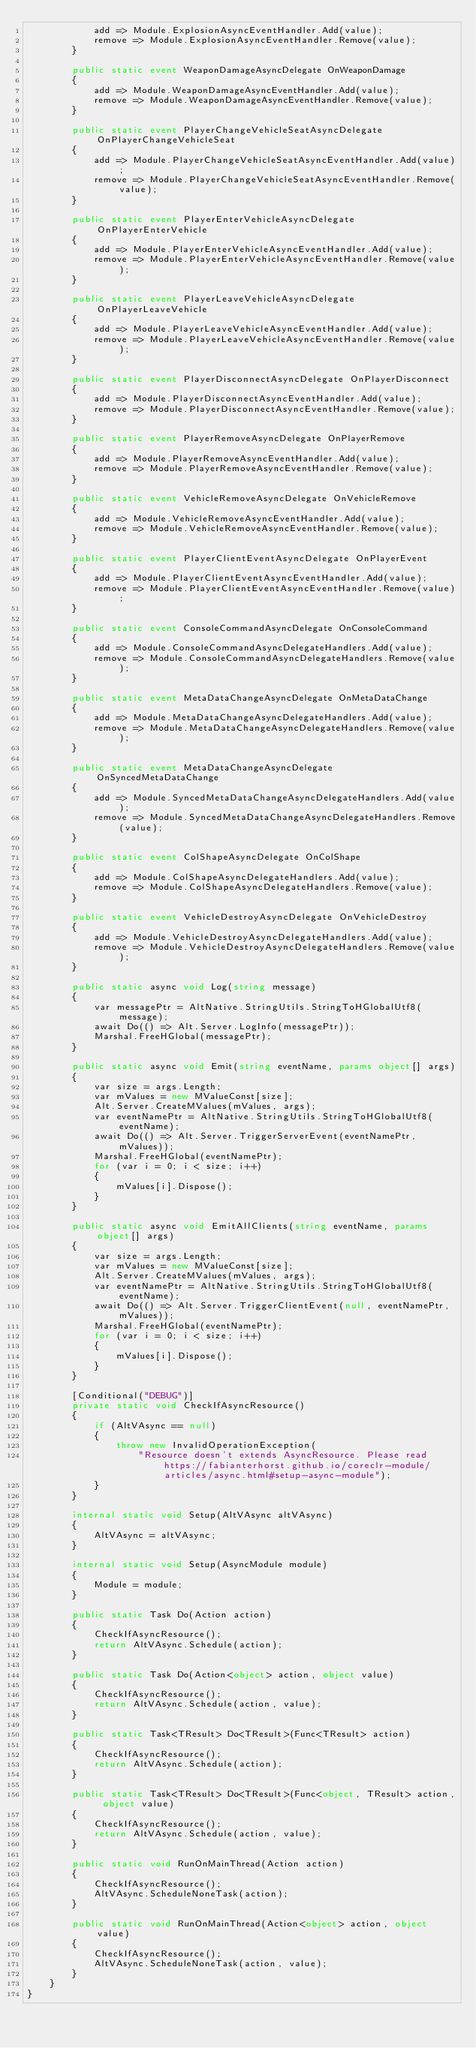<code> <loc_0><loc_0><loc_500><loc_500><_C#_>            add => Module.ExplosionAsyncEventHandler.Add(value);
            remove => Module.ExplosionAsyncEventHandler.Remove(value);
        }

        public static event WeaponDamageAsyncDelegate OnWeaponDamage
        {
            add => Module.WeaponDamageAsyncEventHandler.Add(value);
            remove => Module.WeaponDamageAsyncEventHandler.Remove(value);
        }

        public static event PlayerChangeVehicleSeatAsyncDelegate OnPlayerChangeVehicleSeat
        {
            add => Module.PlayerChangeVehicleSeatAsyncEventHandler.Add(value);
            remove => Module.PlayerChangeVehicleSeatAsyncEventHandler.Remove(value);
        }

        public static event PlayerEnterVehicleAsyncDelegate OnPlayerEnterVehicle
        {
            add => Module.PlayerEnterVehicleAsyncEventHandler.Add(value);
            remove => Module.PlayerEnterVehicleAsyncEventHandler.Remove(value);
        }

        public static event PlayerLeaveVehicleAsyncDelegate OnPlayerLeaveVehicle
        {
            add => Module.PlayerLeaveVehicleAsyncEventHandler.Add(value);
            remove => Module.PlayerLeaveVehicleAsyncEventHandler.Remove(value);
        }

        public static event PlayerDisconnectAsyncDelegate OnPlayerDisconnect
        {
            add => Module.PlayerDisconnectAsyncEventHandler.Add(value);
            remove => Module.PlayerDisconnectAsyncEventHandler.Remove(value);
        }

        public static event PlayerRemoveAsyncDelegate OnPlayerRemove
        {
            add => Module.PlayerRemoveAsyncEventHandler.Add(value);
            remove => Module.PlayerRemoveAsyncEventHandler.Remove(value);
        }

        public static event VehicleRemoveAsyncDelegate OnVehicleRemove
        {
            add => Module.VehicleRemoveAsyncEventHandler.Add(value);
            remove => Module.VehicleRemoveAsyncEventHandler.Remove(value);
        }

        public static event PlayerClientEventAsyncDelegate OnPlayerEvent
        {
            add => Module.PlayerClientEventAsyncEventHandler.Add(value);
            remove => Module.PlayerClientEventAsyncEventHandler.Remove(value);
        }

        public static event ConsoleCommandAsyncDelegate OnConsoleCommand
        {
            add => Module.ConsoleCommandAsyncDelegateHandlers.Add(value);
            remove => Module.ConsoleCommandAsyncDelegateHandlers.Remove(value);
        }

        public static event MetaDataChangeAsyncDelegate OnMetaDataChange
        {
            add => Module.MetaDataChangeAsyncDelegateHandlers.Add(value);
            remove => Module.MetaDataChangeAsyncDelegateHandlers.Remove(value);
        }

        public static event MetaDataChangeAsyncDelegate OnSyncedMetaDataChange
        {
            add => Module.SyncedMetaDataChangeAsyncDelegateHandlers.Add(value);
            remove => Module.SyncedMetaDataChangeAsyncDelegateHandlers.Remove(value);
        }

        public static event ColShapeAsyncDelegate OnColShape
        {
            add => Module.ColShapeAsyncDelegateHandlers.Add(value);
            remove => Module.ColShapeAsyncDelegateHandlers.Remove(value);
        }

        public static event VehicleDestroyAsyncDelegate OnVehicleDestroy
        {
            add => Module.VehicleDestroyAsyncDelegateHandlers.Add(value);
            remove => Module.VehicleDestroyAsyncDelegateHandlers.Remove(value);
        }

        public static async void Log(string message)
        {
            var messagePtr = AltNative.StringUtils.StringToHGlobalUtf8(message);
            await Do(() => Alt.Server.LogInfo(messagePtr));
            Marshal.FreeHGlobal(messagePtr);
        }

        public static async void Emit(string eventName, params object[] args)
        {
            var size = args.Length;
            var mValues = new MValueConst[size];
            Alt.Server.CreateMValues(mValues, args);
            var eventNamePtr = AltNative.StringUtils.StringToHGlobalUtf8(eventName);
            await Do(() => Alt.Server.TriggerServerEvent(eventNamePtr, mValues));
            Marshal.FreeHGlobal(eventNamePtr);
            for (var i = 0; i < size; i++)
            {
                mValues[i].Dispose();
            }
        }

        public static async void EmitAllClients(string eventName, params object[] args)
        {
            var size = args.Length;
            var mValues = new MValueConst[size];
            Alt.Server.CreateMValues(mValues, args);
            var eventNamePtr = AltNative.StringUtils.StringToHGlobalUtf8(eventName);
            await Do(() => Alt.Server.TriggerClientEvent(null, eventNamePtr, mValues));
            Marshal.FreeHGlobal(eventNamePtr);
            for (var i = 0; i < size; i++)
            {
                mValues[i].Dispose();
            }
        }

        [Conditional("DEBUG")]
        private static void CheckIfAsyncResource()
        {
            if (AltVAsync == null)
            {
                throw new InvalidOperationException(
                    "Resource doesn't extends AsyncResource. Please read https://fabianterhorst.github.io/coreclr-module/articles/async.html#setup-async-module");
            }
        }

        internal static void Setup(AltVAsync altVAsync)
        {
            AltVAsync = altVAsync;
        }

        internal static void Setup(AsyncModule module)
        {
            Module = module;
        }

        public static Task Do(Action action)
        {
            CheckIfAsyncResource();
            return AltVAsync.Schedule(action);
        }

        public static Task Do(Action<object> action, object value)
        {
            CheckIfAsyncResource();
            return AltVAsync.Schedule(action, value);
        }

        public static Task<TResult> Do<TResult>(Func<TResult> action)
        {
            CheckIfAsyncResource();
            return AltVAsync.Schedule(action);
        }

        public static Task<TResult> Do<TResult>(Func<object, TResult> action, object value)
        {
            CheckIfAsyncResource();
            return AltVAsync.Schedule(action, value);
        }

        public static void RunOnMainThread(Action action)
        {
            CheckIfAsyncResource();
            AltVAsync.ScheduleNoneTask(action);
        }

        public static void RunOnMainThread(Action<object> action, object value)
        {
            CheckIfAsyncResource();
            AltVAsync.ScheduleNoneTask(action, value);
        }
    }
}</code> 